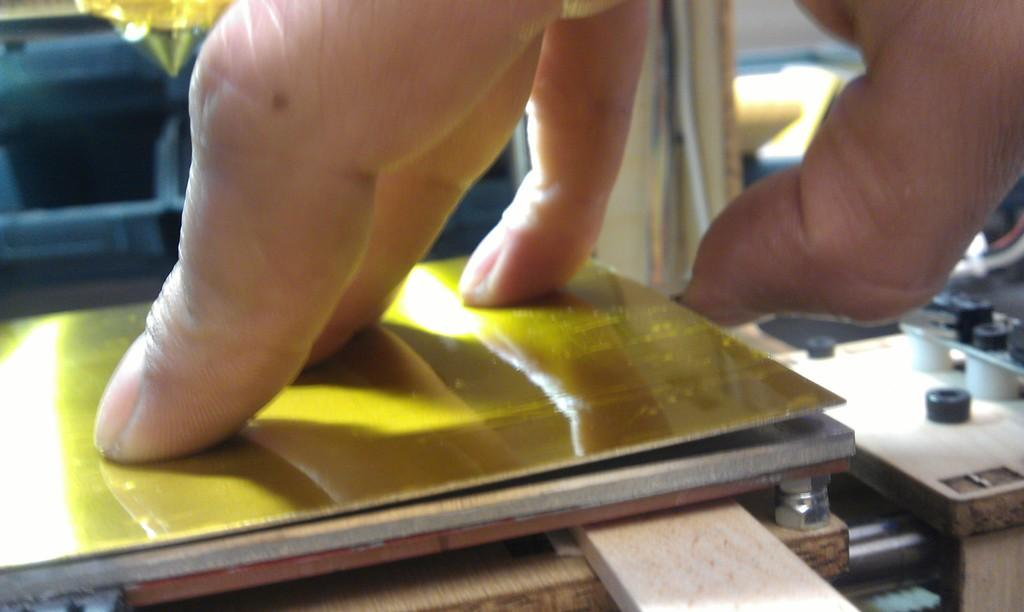What body part is visible in the image? There are fingers of a person in the image. What type of object is yellow and present in the image? There is a yellow color board in the image. What type of hardware can be seen in the image? There are bolts in the image. How many beds are visible in the image? There are no beds present in the image. What type of plot is being developed in the image? There is no plot being developed in the image; it features fingers, a yellow color board, and bolts. 